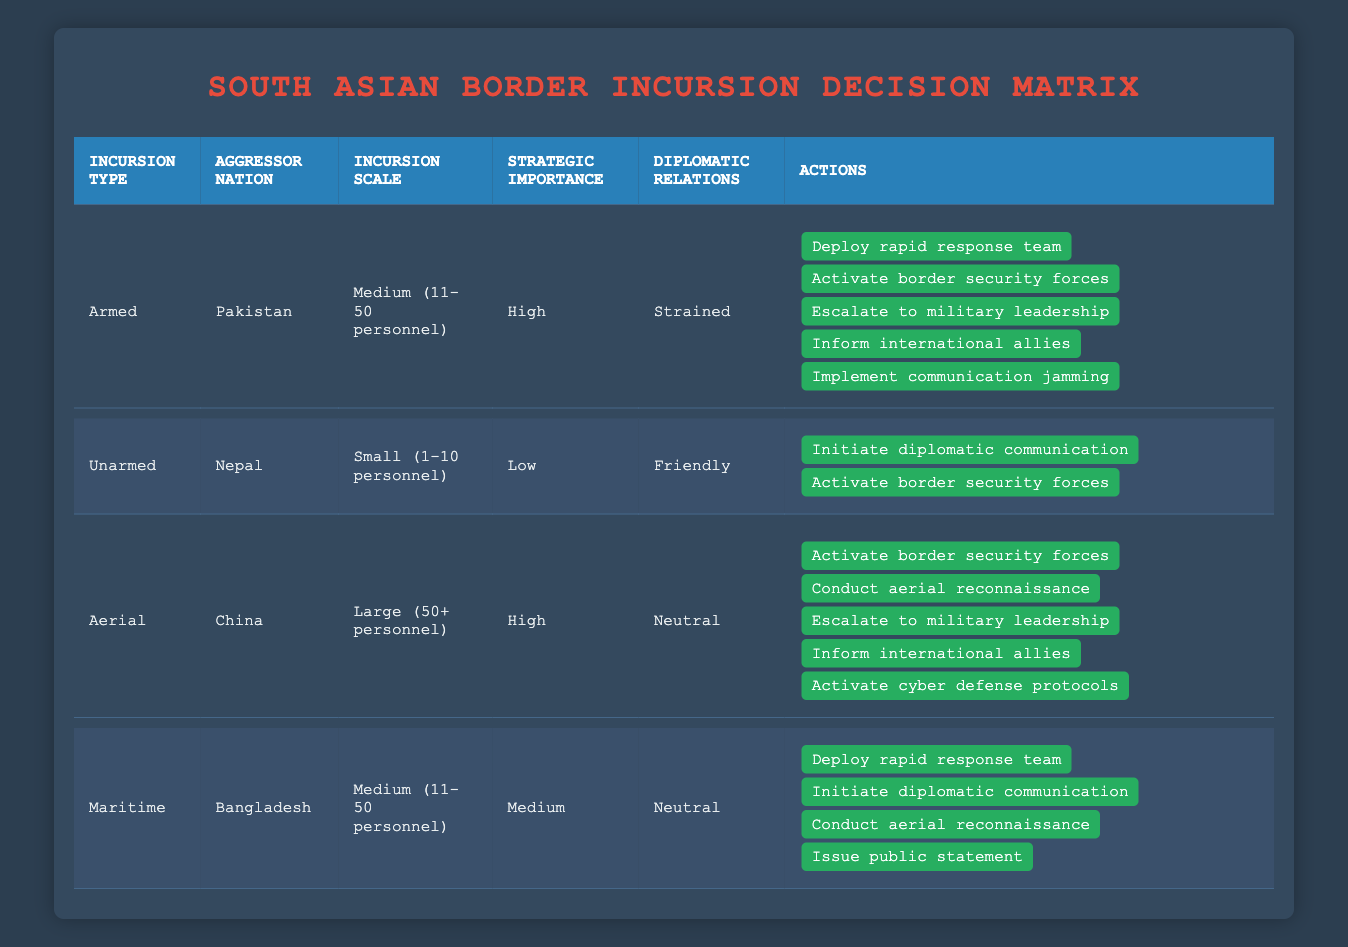What actions are taken in response to an armed incursion by Pakistan? The table indicates that for an armed incursion by Pakistan with a medium scale and high strategic importance in the case of strained diplomatic relations, the actions taken are: deploy rapid response team, activate border security forces, escalate to military leadership, inform international allies, and implement communication jamming.
Answer: Deploy rapid response team, activate border security forces, escalate to military leadership, inform international allies, implement communication jamming Are there any actions specified for unarmed incursions from Nepal? Yes, the table states that for an unarmed incursion by Nepal with a small scale and low strategic importance while maintaining friendly diplomatic relations, the actions specified are to initiate diplomatic communication and activate border security forces.
Answer: Yes What is the total number of actions listed for aerial incursions? For aerial incursions, the table indicates that five actions are specified: activate border security forces, conduct aerial reconnaissance, escalate to military leadership, inform international allies, and activate cyber defense protocols. Therefore, the total number of actions is five.
Answer: 5 If there is a maritime incursion from Bangladesh, what is the scale of personnel involved? Looking at the table, the scale of personnel involved in a maritime incursion from Bangladesh is medium, with the specified range of 11-50 personnel.
Answer: Medium (11-50 personnel) Is the strategic importance of the area a factor for all incursions listed? Yes, the table shows that each incursion listed—armed, unarmed, aerial, and maritime—includes a designation for the strategic importance of the area as low, medium, or high, making it a factor for all.
Answer: Yes What actions are common between armed incursions by Pakistan and maritime incursions by Bangladesh? The table shows that both incidents involve activating border security forces, making it the common action for both armed incursions by Pakistan and maritime incursions from Bangladesh. Further comparison reveals other actions differ.
Answer: Activate border security forces What would be the response if there is a large aerial incursion by China? Based on the table, if there is a large aerial incursion by China, the actions would include activating border security forces, conducting aerial reconnaissance, escalating to military leadership, informing international allies, and activating cyber defense protocols. All these actions indicate a strong response due to the high stakes involved.
Answer: Activate border security forces, conduct aerial reconnaissance, escalate to military leadership, inform international allies, activate cyber defense protocols Given the current relations, how does the response differ for Nepal's unarmed incursions compared to Pakistan's armed incursions? For Nepal's unarmed incursions, the actions are limited to initiating diplomatic communication and activating border security forces, reflecting friendly relations and low-scale threat. In contrast, Pakistan's armed incursions result in more aggressive measures including deploying rapid response teams and jamming communications, due to strained relations and a higher assessment of threat. This comparison highlights the impact of diplomatic relations on decision-making.
Answer: The response for Nepal is diplomatic and low-scale; for Pakistan, it is militaristic and comprehensive 